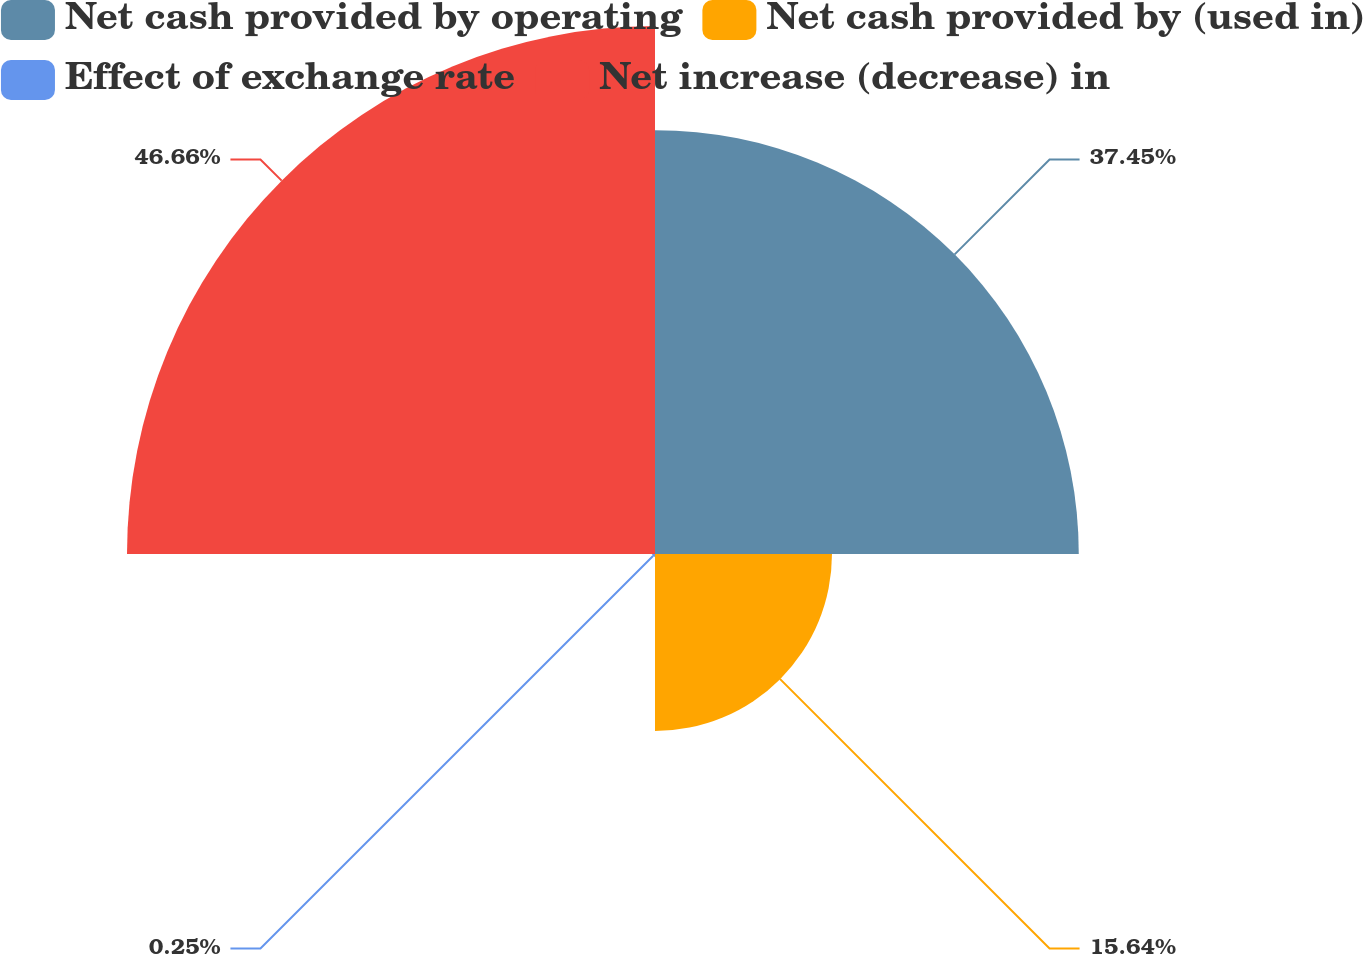Convert chart. <chart><loc_0><loc_0><loc_500><loc_500><pie_chart><fcel>Net cash provided by operating<fcel>Net cash provided by (used in)<fcel>Effect of exchange rate<fcel>Net increase (decrease) in<nl><fcel>37.45%<fcel>15.64%<fcel>0.25%<fcel>46.66%<nl></chart> 